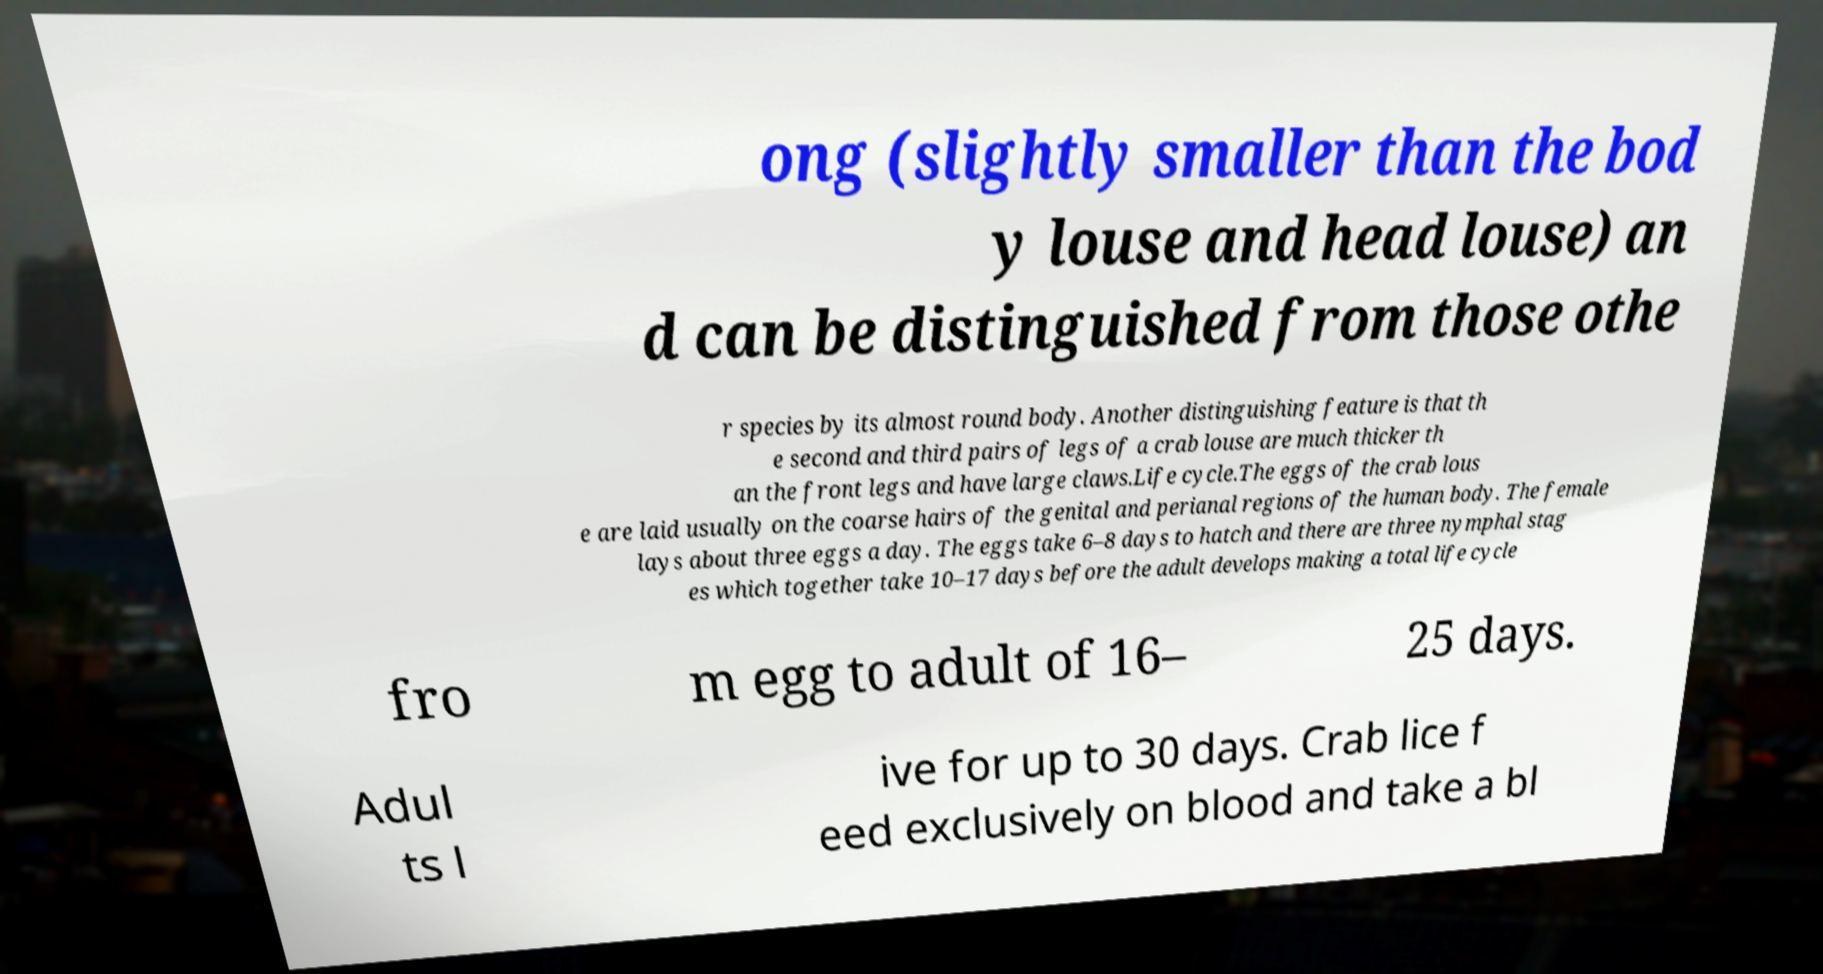There's text embedded in this image that I need extracted. Can you transcribe it verbatim? ong (slightly smaller than the bod y louse and head louse) an d can be distinguished from those othe r species by its almost round body. Another distinguishing feature is that th e second and third pairs of legs of a crab louse are much thicker th an the front legs and have large claws.Life cycle.The eggs of the crab lous e are laid usually on the coarse hairs of the genital and perianal regions of the human body. The female lays about three eggs a day. The eggs take 6–8 days to hatch and there are three nymphal stag es which together take 10–17 days before the adult develops making a total life cycle fro m egg to adult of 16– 25 days. Adul ts l ive for up to 30 days. Crab lice f eed exclusively on blood and take a bl 